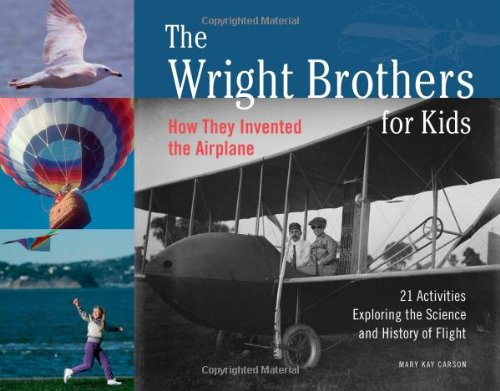What are some of the educational activities included in this book related to flight? The book includes 21 fun activities such as making a simple kite, building a rubber band-powered flyer, and designing a model parachute, which help children understand the principles of flight through practical experiments. 